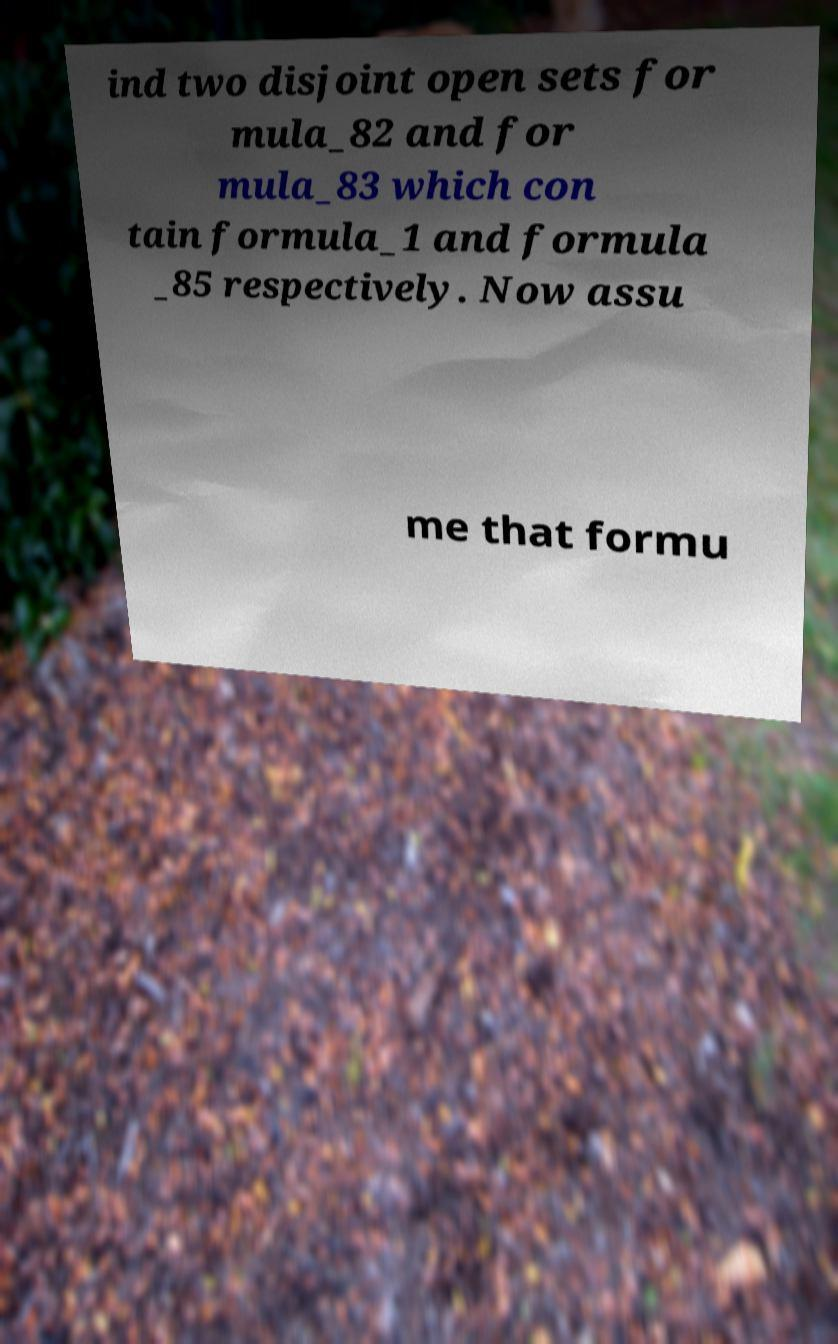I need the written content from this picture converted into text. Can you do that? ind two disjoint open sets for mula_82 and for mula_83 which con tain formula_1 and formula _85 respectively. Now assu me that formu 